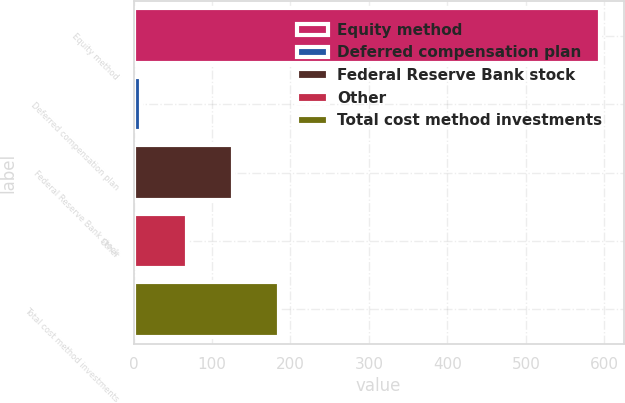Convert chart to OTSL. <chart><loc_0><loc_0><loc_500><loc_500><bar_chart><fcel>Equity method<fcel>Deferred compensation plan<fcel>Federal Reserve Bank stock<fcel>Other<fcel>Total cost method investments<nl><fcel>595<fcel>9<fcel>126.2<fcel>67.6<fcel>184.8<nl></chart> 